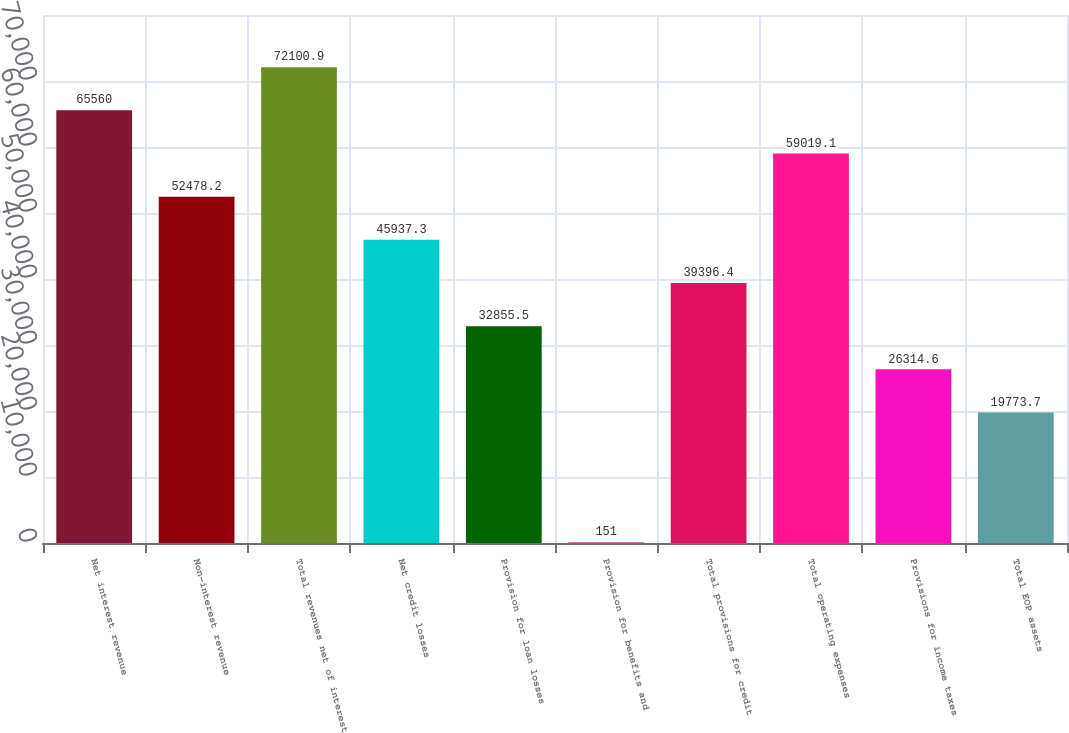Convert chart to OTSL. <chart><loc_0><loc_0><loc_500><loc_500><bar_chart><fcel>Net interest revenue<fcel>Non-interest revenue<fcel>Total revenues net of interest<fcel>Net credit losses<fcel>Provision for loan losses<fcel>Provision for benefits and<fcel>Total provisions for credit<fcel>Total operating expenses<fcel>Provisions for income taxes<fcel>Total EOP assets<nl><fcel>65560<fcel>52478.2<fcel>72100.9<fcel>45937.3<fcel>32855.5<fcel>151<fcel>39396.4<fcel>59019.1<fcel>26314.6<fcel>19773.7<nl></chart> 